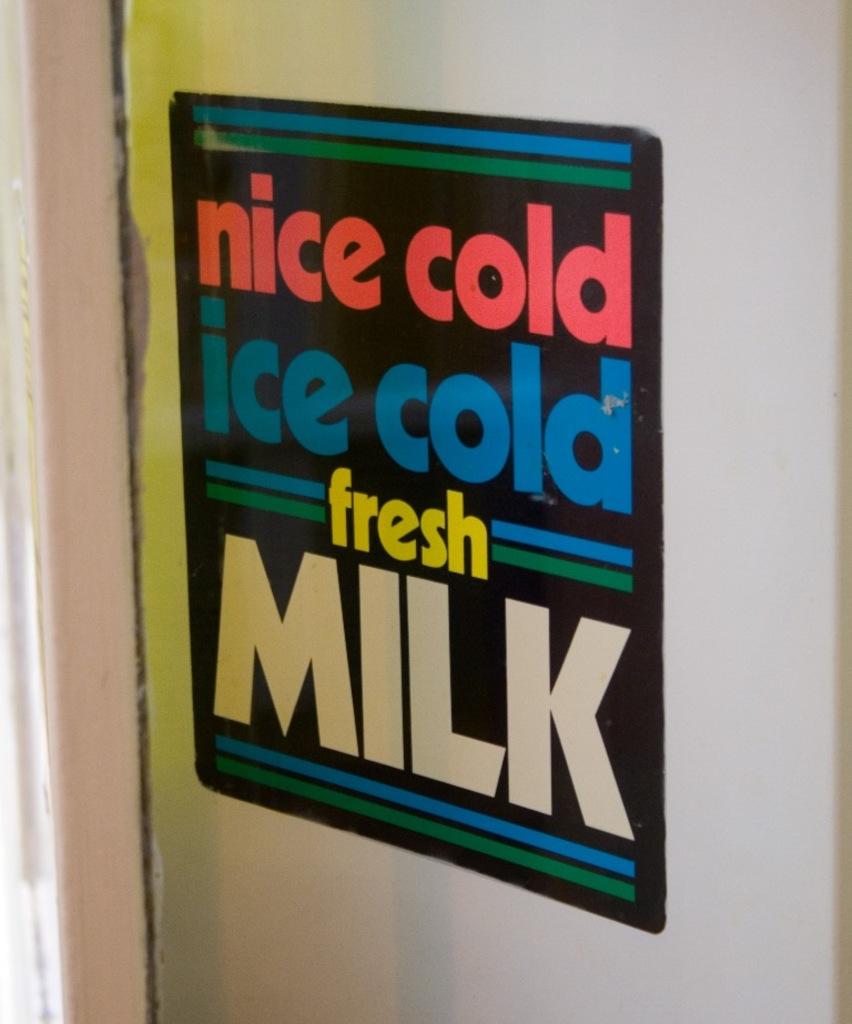What type of fresh milk does it say?
Make the answer very short. Ice cold. Is the milk hot?
Offer a terse response. No. 